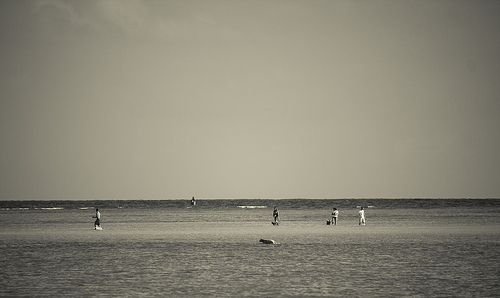Explore the theme of isolation in this image. Although people are present, their dispersed arrangement across the wide beach creates an impression of isolation, highlighting the individual's place within the vast environment. What activities are the people engaged in? The individuals seem to be partaking in meditative walks, leisurely strolls with pets, or simply standing and absorbing the scene, each finding solace in their own way. 